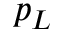Convert formula to latex. <formula><loc_0><loc_0><loc_500><loc_500>p _ { L }</formula> 